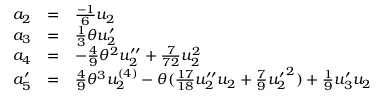<formula> <loc_0><loc_0><loc_500><loc_500>\begin{array} { l c l } { { a _ { 2 } } } & { = } & { { \frac { - 1 } { 6 } u _ { 2 } } } \\ { { a _ { 3 } } } & { = } & { { \frac { 1 } { 3 } \theta u _ { 2 } ^ { \prime } } } \\ { { a _ { 4 } } } & { = } & { { - \frac { 4 } { 9 } { \theta } ^ { 2 } u _ { 2 } ^ { \prime \prime } + \frac { 7 } { 7 2 } u _ { 2 } ^ { 2 } } } \\ { { a _ { 5 } ^ { \prime } } } & { = } & { { \frac { 4 } { 9 } { \theta } ^ { 3 } u _ { 2 } ^ { ( 4 ) } - \theta ( \frac { 1 7 } { 1 8 } u _ { 2 } ^ { \prime \prime } u _ { 2 } + \frac { 7 } { 9 } { u _ { 2 } ^ { \prime } } ^ { 2 } ) + \frac { 1 } { 9 } u _ { 3 } ^ { \prime } u _ { 2 } } } \end{array}</formula> 